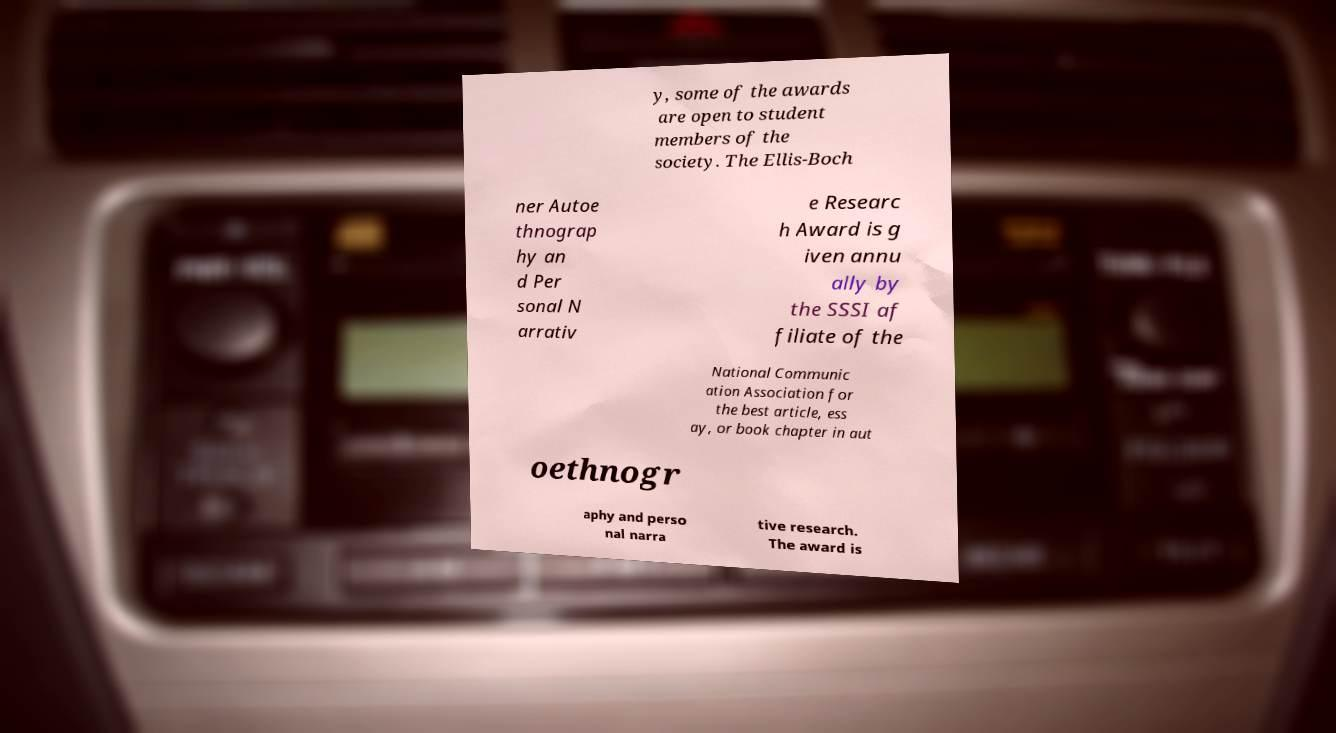Can you accurately transcribe the text from the provided image for me? y, some of the awards are open to student members of the society. The Ellis-Boch ner Autoe thnograp hy an d Per sonal N arrativ e Researc h Award is g iven annu ally by the SSSI af filiate of the National Communic ation Association for the best article, ess ay, or book chapter in aut oethnogr aphy and perso nal narra tive research. The award is 